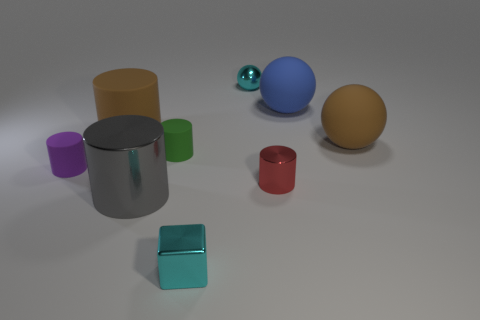How many tiny things are there?
Make the answer very short. 5. Does the metal cylinder that is on the right side of the tiny cyan shiny ball have the same color as the small object in front of the tiny metal cylinder?
Ensure brevity in your answer.  No. What number of cylinders are behind the tiny red object?
Keep it short and to the point. 3. There is a small ball that is the same color as the cube; what is its material?
Make the answer very short. Metal. Is there another blue thing that has the same shape as the blue rubber object?
Make the answer very short. No. Is the material of the large brown thing to the left of the cyan block the same as the small cylinder behind the small purple thing?
Provide a short and direct response. Yes. What is the size of the thing that is to the left of the big brown thing that is on the left side of the small green rubber object that is in front of the small cyan metal sphere?
Provide a succinct answer. Small. There is a gray thing that is the same size as the blue matte sphere; what is it made of?
Ensure brevity in your answer.  Metal. Is there a brown metallic cylinder that has the same size as the shiny sphere?
Your answer should be compact. No. Does the small purple object have the same shape as the tiny red shiny object?
Offer a terse response. Yes. 